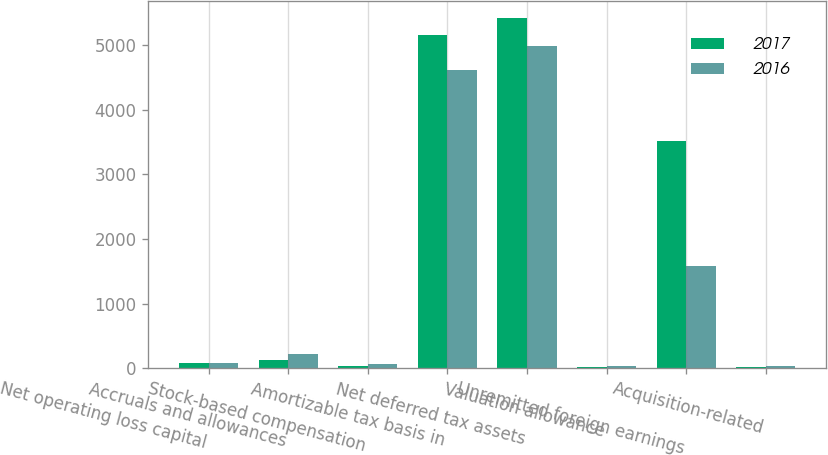Convert chart to OTSL. <chart><loc_0><loc_0><loc_500><loc_500><stacked_bar_chart><ecel><fcel>Net operating loss capital<fcel>Accruals and allowances<fcel>Stock-based compensation<fcel>Amortizable tax basis in<fcel>Net deferred tax assets<fcel>Valuation allowance<fcel>Unremitted foreign earnings<fcel>Acquisition-related<nl><fcel>2017<fcel>86<fcel>129<fcel>40<fcel>5164<fcel>5419<fcel>19<fcel>3514<fcel>24<nl><fcel>2016<fcel>78<fcel>222<fcel>65<fcel>4621<fcel>4986<fcel>37<fcel>1578<fcel>29<nl></chart> 